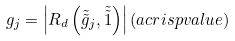<formula> <loc_0><loc_0><loc_500><loc_500>g _ { j } = \left | R _ { d } \left ( \tilde { \tilde { g } } _ { j } , \tilde { \tilde { 1 } } \right ) \right | ( a c r i s p v a l u e )</formula> 